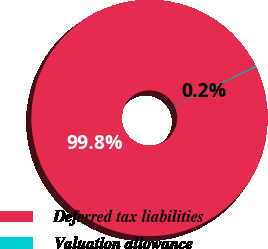Convert chart. <chart><loc_0><loc_0><loc_500><loc_500><pie_chart><fcel>Deferred tax liabilities<fcel>Valuation allowance<nl><fcel>99.84%<fcel>0.16%<nl></chart> 